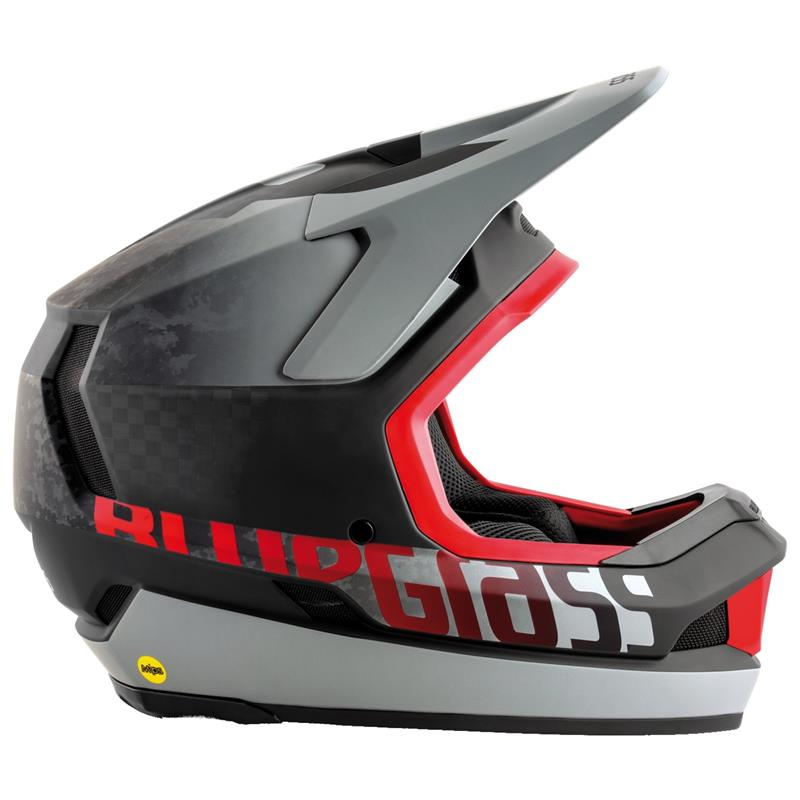How does the aerodynamic design of the helmet contribute to a rider's experience? The aerodynamic design of this helmet serves multiple purposes that enhance the rider's experience. By reducing air resistance, it allows for smoother and faster movement, which is especially beneficial in high-speed activities like downhill biking or motorcycling. The streamlined shape also helps to minimize wind noise, making for a quieter, more enjoyable ride. Additionally, the design often includes strategically placed vents that promote airflow, keeping the rider cool and comfortable. Overall, the aerodynamic features not only improve performance but also contribute to the overall safety and comfort of the rider. Could you detail how the ventilation system might be structured in this helmet? Certainly! The ventilation system in this helmet likely comprises several key components, designed to ensure efficient airflow and maintain user comfort. The exterior of the helmet typically features multiple intake vents strategically placed at the front and crown areas. These allow cool air to enter. Inside, channels carved into the EPS foam facilitate the movement of air across the head. This airflow helps dissipate heat, preventing overheating during intense activity. Exhaust vents located at the rear or sides of the helmet enable the warm air to escape, ensuring a continuous flow. Together, these elements create a comprehensive ventilation system that keeps the rider cool and focused, even during long or strenuous rides. 